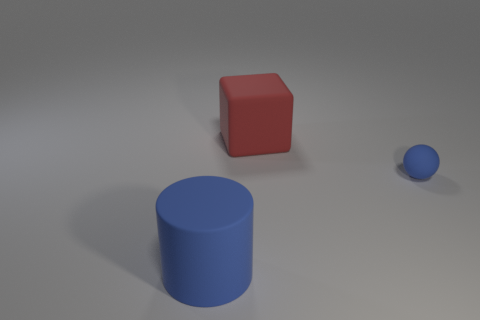Add 1 big cyan spheres. How many objects exist? 4 Subtract all cylinders. How many objects are left? 2 Add 3 blue rubber things. How many blue rubber things exist? 5 Subtract 1 blue spheres. How many objects are left? 2 Subtract all big matte cylinders. Subtract all tiny spheres. How many objects are left? 1 Add 1 cubes. How many cubes are left? 2 